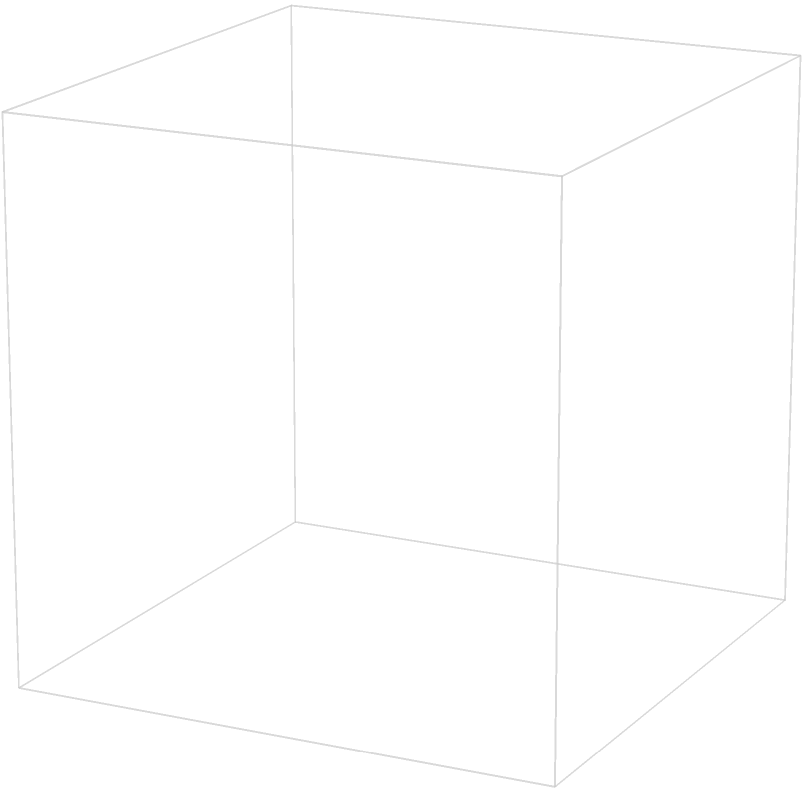In a quality control system for a cubic manufacturing space with dimensions 1x1x1 units, five sensors (A, B, C, D, and E) are placed at the vertices of the cube as shown in the diagram. Each sensor has a spherical coverage area with a radius of 0.5 units. What is the volume of the region within the cube that is covered by at least one sensor's detection area? Express your answer as a fraction of the total cube volume. To solve this problem, we'll follow these steps:

1) First, let's consider the volume of the cube:
   $V_{cube} = 1 \times 1 \times 1 = 1$ cubic unit

2) Now, let's calculate the volume of a single sensor's coverage within the cube:
   The volume of a sphere is $V_{sphere} = \frac{4}{3}\pi r^3$
   With $r = 0.5$, $V_{sphere} = \frac{4}{3}\pi (0.5)^3 = \frac{\pi}{6}$ cubic units

3) However, only half of this sphere is within the cube for corner sensors:
   $V_{corner} = \frac{1}{2} \times \frac{\pi}{6} = \frac{\pi}{12}$ cubic units

4) There are 5 such corner spheres (A, B, C, D, and E)

5) The total volume covered would be $5 \times \frac{\pi}{12}$ if there were no overlaps

6) However, there are significant overlaps between these spheres

7) The exact calculation of these overlaps is complex, but we can use the fact that the center of the cube (0.5, 0.5, 0.5) is exactly 0.5 units away from each corner

8) This means that the coverage areas of all 5 sensors meet at the center of the cube, covering it entirely

9) Therefore, the covered volume is actually the entire cube minus small uncovered corners

10) These uncovered corners are each $\frac{1}{8}$ of the volume not covered by a corner sensor

11) The volume not covered by a corner sensor is $\frac{1}{8} - \frac{\pi}{96}$

12) There are 8 such corners, so the total uncovered volume is:
    $V_{uncovered} = 8 \times (\frac{1}{8} - \frac{\pi}{96}) = 1 - \frac{\pi}{12}$

13) Therefore, the covered volume is:
    $V_{covered} = 1 - (1 - \frac{\pi}{12}) = \frac{\pi}{12}$

14) As a fraction of the total cube volume:
    $\frac{V_{covered}}{V_{cube}} = \frac{\pi}{12}$
Answer: $\frac{\pi}{12}$ 